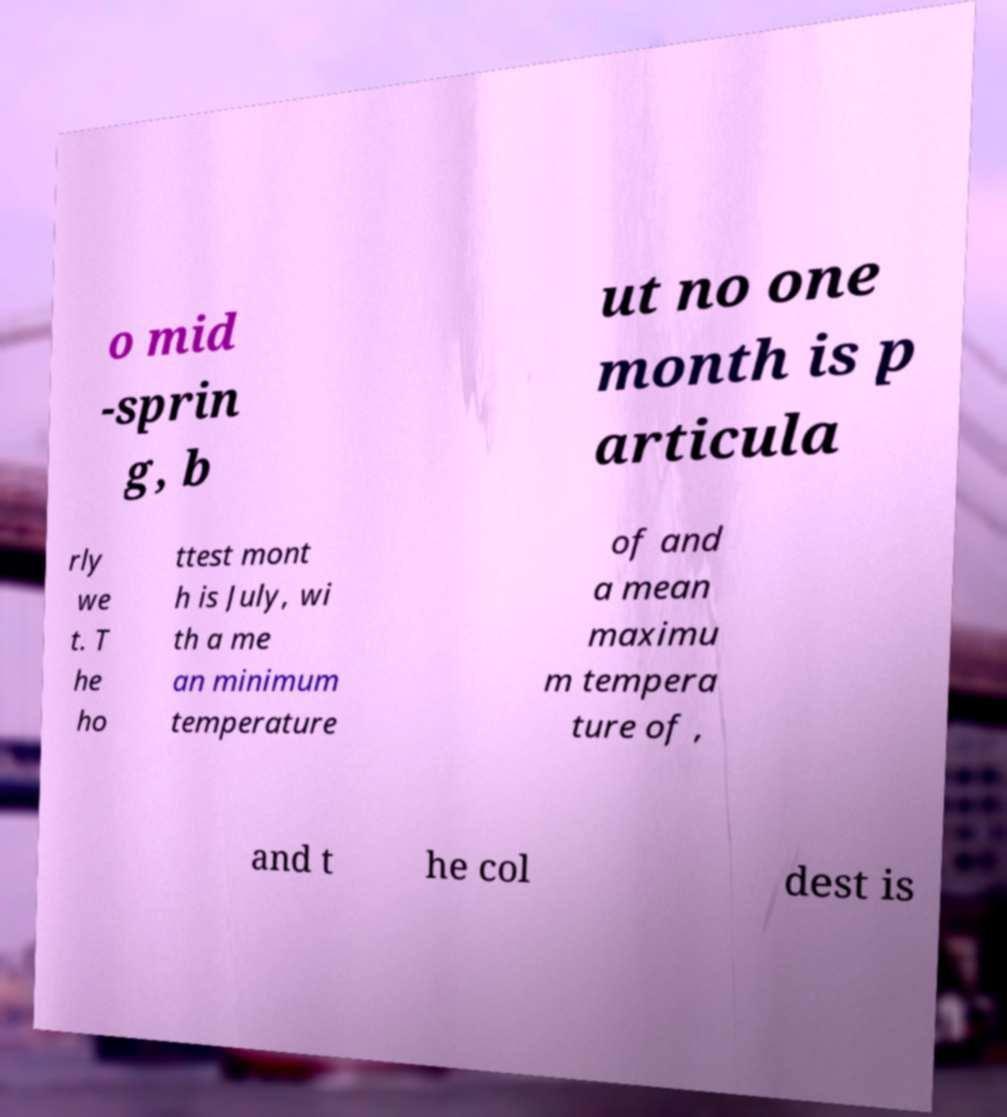Please read and relay the text visible in this image. What does it say? o mid -sprin g, b ut no one month is p articula rly we t. T he ho ttest mont h is July, wi th a me an minimum temperature of and a mean maximu m tempera ture of , and t he col dest is 